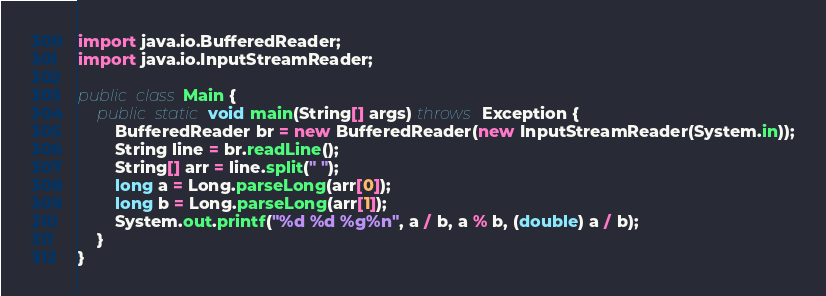<code> <loc_0><loc_0><loc_500><loc_500><_Java_>import java.io.BufferedReader;
import java.io.InputStreamReader;

public class Main {
	public static void main(String[] args) throws Exception {
		BufferedReader br = new BufferedReader(new InputStreamReader(System.in));
		String line = br.readLine();
		String[] arr = line.split(" ");
		long a = Long.parseLong(arr[0]);
		long b = Long.parseLong(arr[1]);
		System.out.printf("%d %d %g%n", a / b, a % b, (double) a / b);
	}
}</code> 